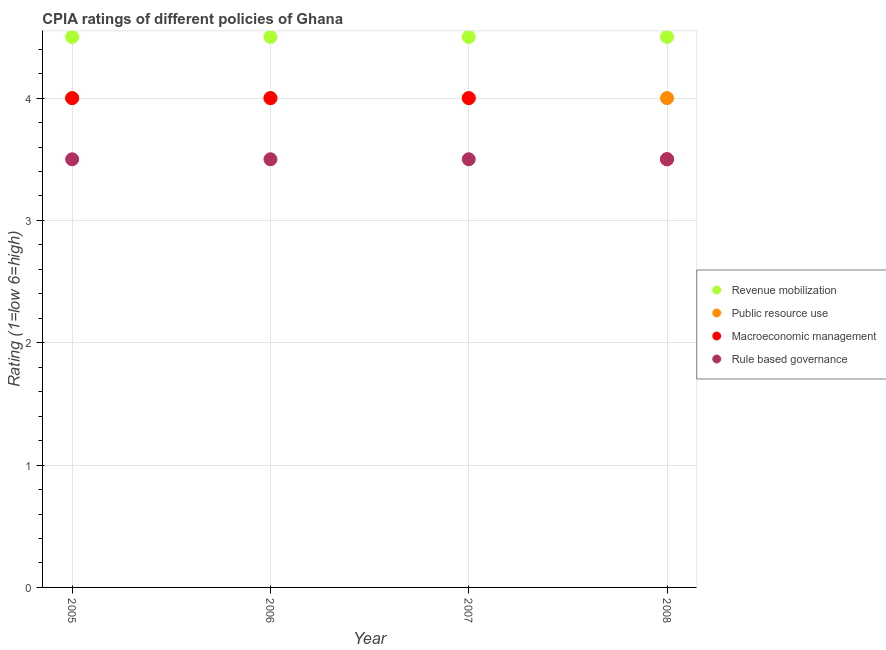How many different coloured dotlines are there?
Your response must be concise. 4. Is the number of dotlines equal to the number of legend labels?
Make the answer very short. Yes. What is the cpia rating of macroeconomic management in 2007?
Your answer should be very brief. 4. Across all years, what is the minimum cpia rating of public resource use?
Provide a succinct answer. 4. In which year was the cpia rating of public resource use maximum?
Ensure brevity in your answer.  2005. What is the total cpia rating of macroeconomic management in the graph?
Your response must be concise. 15.5. What is the average cpia rating of revenue mobilization per year?
Keep it short and to the point. 4.5. In how many years, is the cpia rating of revenue mobilization greater than 3.2?
Keep it short and to the point. 4. What is the difference between the highest and the second highest cpia rating of macroeconomic management?
Give a very brief answer. 0. What is the difference between the highest and the lowest cpia rating of macroeconomic management?
Offer a terse response. 0.5. In how many years, is the cpia rating of rule based governance greater than the average cpia rating of rule based governance taken over all years?
Your answer should be compact. 0. Is the sum of the cpia rating of macroeconomic management in 2005 and 2008 greater than the maximum cpia rating of rule based governance across all years?
Your answer should be compact. Yes. Is it the case that in every year, the sum of the cpia rating of revenue mobilization and cpia rating of macroeconomic management is greater than the sum of cpia rating of public resource use and cpia rating of rule based governance?
Offer a terse response. No. Is the cpia rating of public resource use strictly greater than the cpia rating of rule based governance over the years?
Your answer should be very brief. Yes. How many dotlines are there?
Provide a succinct answer. 4. How many years are there in the graph?
Give a very brief answer. 4. Does the graph contain any zero values?
Ensure brevity in your answer.  No. Where does the legend appear in the graph?
Provide a succinct answer. Center right. How are the legend labels stacked?
Your answer should be very brief. Vertical. What is the title of the graph?
Your answer should be very brief. CPIA ratings of different policies of Ghana. Does "Agriculture" appear as one of the legend labels in the graph?
Ensure brevity in your answer.  No. What is the label or title of the X-axis?
Your response must be concise. Year. What is the label or title of the Y-axis?
Keep it short and to the point. Rating (1=low 6=high). What is the Rating (1=low 6=high) in Revenue mobilization in 2005?
Offer a very short reply. 4.5. What is the Rating (1=low 6=high) of Public resource use in 2005?
Your answer should be compact. 4. What is the Rating (1=low 6=high) of Macroeconomic management in 2005?
Your answer should be very brief. 4. What is the Rating (1=low 6=high) in Rule based governance in 2006?
Give a very brief answer. 3.5. What is the Rating (1=low 6=high) in Macroeconomic management in 2008?
Keep it short and to the point. 3.5. What is the Rating (1=low 6=high) of Rule based governance in 2008?
Keep it short and to the point. 3.5. Across all years, what is the maximum Rating (1=low 6=high) of Public resource use?
Your response must be concise. 4. Across all years, what is the minimum Rating (1=low 6=high) of Public resource use?
Ensure brevity in your answer.  4. Across all years, what is the minimum Rating (1=low 6=high) in Macroeconomic management?
Give a very brief answer. 3.5. Across all years, what is the minimum Rating (1=low 6=high) of Rule based governance?
Your answer should be very brief. 3.5. What is the total Rating (1=low 6=high) in Revenue mobilization in the graph?
Provide a short and direct response. 18. What is the total Rating (1=low 6=high) of Public resource use in the graph?
Your answer should be very brief. 16. What is the difference between the Rating (1=low 6=high) in Macroeconomic management in 2005 and that in 2006?
Your response must be concise. 0. What is the difference between the Rating (1=low 6=high) in Revenue mobilization in 2005 and that in 2008?
Provide a short and direct response. 0. What is the difference between the Rating (1=low 6=high) in Macroeconomic management in 2005 and that in 2008?
Offer a terse response. 0.5. What is the difference between the Rating (1=low 6=high) in Public resource use in 2006 and that in 2007?
Give a very brief answer. 0. What is the difference between the Rating (1=low 6=high) in Revenue mobilization in 2006 and that in 2008?
Make the answer very short. 0. What is the difference between the Rating (1=low 6=high) in Public resource use in 2006 and that in 2008?
Your response must be concise. 0. What is the difference between the Rating (1=low 6=high) in Revenue mobilization in 2007 and that in 2008?
Make the answer very short. 0. What is the difference between the Rating (1=low 6=high) in Public resource use in 2007 and that in 2008?
Your response must be concise. 0. What is the difference between the Rating (1=low 6=high) in Macroeconomic management in 2007 and that in 2008?
Offer a very short reply. 0.5. What is the difference between the Rating (1=low 6=high) in Revenue mobilization in 2005 and the Rating (1=low 6=high) in Macroeconomic management in 2006?
Give a very brief answer. 0.5. What is the difference between the Rating (1=low 6=high) of Revenue mobilization in 2005 and the Rating (1=low 6=high) of Rule based governance in 2006?
Keep it short and to the point. 1. What is the difference between the Rating (1=low 6=high) of Revenue mobilization in 2005 and the Rating (1=low 6=high) of Rule based governance in 2007?
Your answer should be very brief. 1. What is the difference between the Rating (1=low 6=high) of Public resource use in 2005 and the Rating (1=low 6=high) of Macroeconomic management in 2007?
Your response must be concise. 0. What is the difference between the Rating (1=low 6=high) of Public resource use in 2005 and the Rating (1=low 6=high) of Rule based governance in 2007?
Give a very brief answer. 0.5. What is the difference between the Rating (1=low 6=high) in Macroeconomic management in 2005 and the Rating (1=low 6=high) in Rule based governance in 2008?
Your answer should be very brief. 0.5. What is the difference between the Rating (1=low 6=high) of Revenue mobilization in 2006 and the Rating (1=low 6=high) of Macroeconomic management in 2007?
Offer a terse response. 0.5. What is the difference between the Rating (1=low 6=high) in Public resource use in 2006 and the Rating (1=low 6=high) in Macroeconomic management in 2007?
Make the answer very short. 0. What is the difference between the Rating (1=low 6=high) of Public resource use in 2006 and the Rating (1=low 6=high) of Rule based governance in 2007?
Provide a succinct answer. 0.5. What is the difference between the Rating (1=low 6=high) of Macroeconomic management in 2006 and the Rating (1=low 6=high) of Rule based governance in 2007?
Offer a terse response. 0.5. What is the difference between the Rating (1=low 6=high) of Revenue mobilization in 2006 and the Rating (1=low 6=high) of Public resource use in 2008?
Ensure brevity in your answer.  0.5. What is the difference between the Rating (1=low 6=high) of Revenue mobilization in 2006 and the Rating (1=low 6=high) of Macroeconomic management in 2008?
Offer a terse response. 1. What is the difference between the Rating (1=low 6=high) of Public resource use in 2006 and the Rating (1=low 6=high) of Rule based governance in 2008?
Keep it short and to the point. 0.5. What is the difference between the Rating (1=low 6=high) of Macroeconomic management in 2006 and the Rating (1=low 6=high) of Rule based governance in 2008?
Your answer should be very brief. 0.5. What is the difference between the Rating (1=low 6=high) in Macroeconomic management in 2007 and the Rating (1=low 6=high) in Rule based governance in 2008?
Make the answer very short. 0.5. What is the average Rating (1=low 6=high) of Revenue mobilization per year?
Your response must be concise. 4.5. What is the average Rating (1=low 6=high) in Macroeconomic management per year?
Your response must be concise. 3.88. What is the average Rating (1=low 6=high) of Rule based governance per year?
Your response must be concise. 3.5. In the year 2005, what is the difference between the Rating (1=low 6=high) in Revenue mobilization and Rating (1=low 6=high) in Rule based governance?
Ensure brevity in your answer.  1. In the year 2005, what is the difference between the Rating (1=low 6=high) in Public resource use and Rating (1=low 6=high) in Macroeconomic management?
Your answer should be very brief. 0. In the year 2005, what is the difference between the Rating (1=low 6=high) in Public resource use and Rating (1=low 6=high) in Rule based governance?
Provide a short and direct response. 0.5. In the year 2006, what is the difference between the Rating (1=low 6=high) of Revenue mobilization and Rating (1=low 6=high) of Public resource use?
Give a very brief answer. 0.5. In the year 2006, what is the difference between the Rating (1=low 6=high) of Revenue mobilization and Rating (1=low 6=high) of Macroeconomic management?
Your answer should be very brief. 0.5. In the year 2007, what is the difference between the Rating (1=low 6=high) in Revenue mobilization and Rating (1=low 6=high) in Public resource use?
Offer a terse response. 0.5. In the year 2007, what is the difference between the Rating (1=low 6=high) of Revenue mobilization and Rating (1=low 6=high) of Macroeconomic management?
Your answer should be compact. 0.5. In the year 2007, what is the difference between the Rating (1=low 6=high) in Revenue mobilization and Rating (1=low 6=high) in Rule based governance?
Offer a very short reply. 1. In the year 2008, what is the difference between the Rating (1=low 6=high) of Revenue mobilization and Rating (1=low 6=high) of Public resource use?
Your answer should be compact. 0.5. In the year 2008, what is the difference between the Rating (1=low 6=high) in Public resource use and Rating (1=low 6=high) in Macroeconomic management?
Your response must be concise. 0.5. What is the ratio of the Rating (1=low 6=high) of Public resource use in 2005 to that in 2007?
Provide a short and direct response. 1. What is the ratio of the Rating (1=low 6=high) in Macroeconomic management in 2005 to that in 2007?
Offer a terse response. 1. What is the ratio of the Rating (1=low 6=high) in Rule based governance in 2005 to that in 2007?
Provide a succinct answer. 1. What is the ratio of the Rating (1=low 6=high) of Macroeconomic management in 2005 to that in 2008?
Your answer should be compact. 1.14. What is the ratio of the Rating (1=low 6=high) in Revenue mobilization in 2006 to that in 2007?
Your response must be concise. 1. What is the ratio of the Rating (1=low 6=high) in Public resource use in 2006 to that in 2008?
Your answer should be very brief. 1. What is the ratio of the Rating (1=low 6=high) of Macroeconomic management in 2006 to that in 2008?
Provide a succinct answer. 1.14. What is the ratio of the Rating (1=low 6=high) of Public resource use in 2007 to that in 2008?
Your response must be concise. 1. What is the difference between the highest and the second highest Rating (1=low 6=high) of Public resource use?
Offer a terse response. 0. What is the difference between the highest and the second highest Rating (1=low 6=high) in Macroeconomic management?
Offer a very short reply. 0. What is the difference between the highest and the second highest Rating (1=low 6=high) in Rule based governance?
Give a very brief answer. 0. What is the difference between the highest and the lowest Rating (1=low 6=high) in Macroeconomic management?
Ensure brevity in your answer.  0.5. 